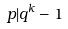Convert formula to latex. <formula><loc_0><loc_0><loc_500><loc_500>p | q ^ { k } - 1</formula> 